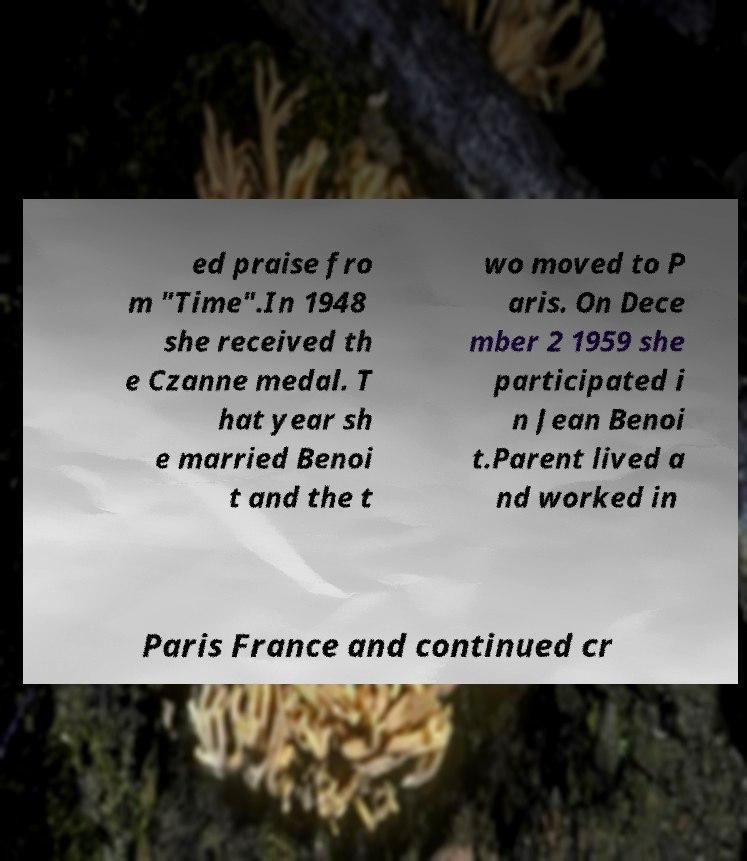What messages or text are displayed in this image? I need them in a readable, typed format. ed praise fro m "Time".In 1948 she received th e Czanne medal. T hat year sh e married Benoi t and the t wo moved to P aris. On Dece mber 2 1959 she participated i n Jean Benoi t.Parent lived a nd worked in Paris France and continued cr 